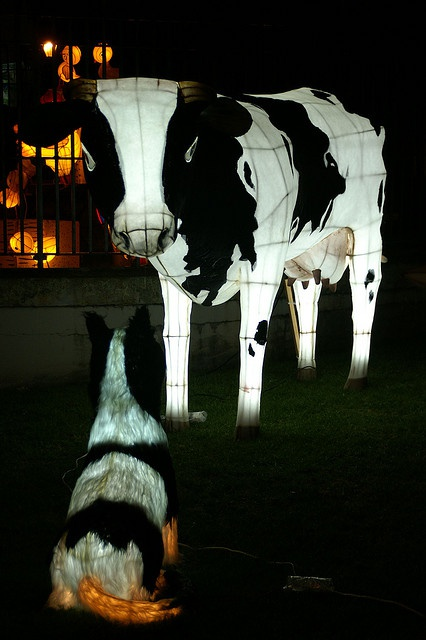Describe the objects in this image and their specific colors. I can see cow in black, ivory, darkgray, and lightgray tones and dog in black, gray, darkgray, and brown tones in this image. 